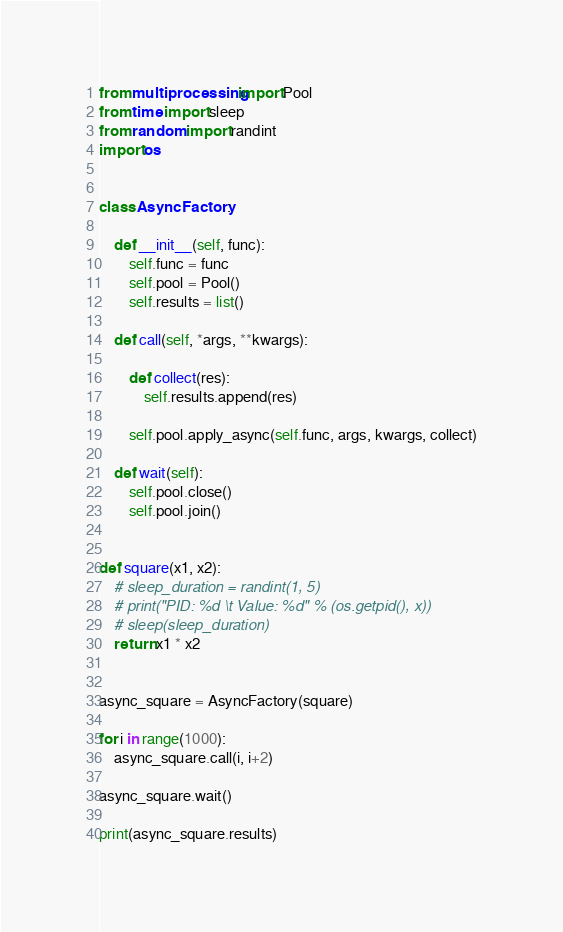Convert code to text. <code><loc_0><loc_0><loc_500><loc_500><_Python_>from multiprocessing import Pool
from time import sleep
from random import randint
import os


class AsyncFactory:

    def __init__(self, func):
        self.func = func
        self.pool = Pool()
        self.results = list()

    def call(self, *args, **kwargs):

        def collect(res):
            self.results.append(res)

        self.pool.apply_async(self.func, args, kwargs, collect)

    def wait(self):
        self.pool.close()
        self.pool.join()


def square(x1, x2):
    # sleep_duration = randint(1, 5)
    # print("PID: %d \t Value: %d" % (os.getpid(), x))
    # sleep(sleep_duration)
    return x1 * x2


async_square = AsyncFactory(square)

for i in range(1000):
    async_square.call(i, i+2)

async_square.wait()

print(async_square.results)
</code> 